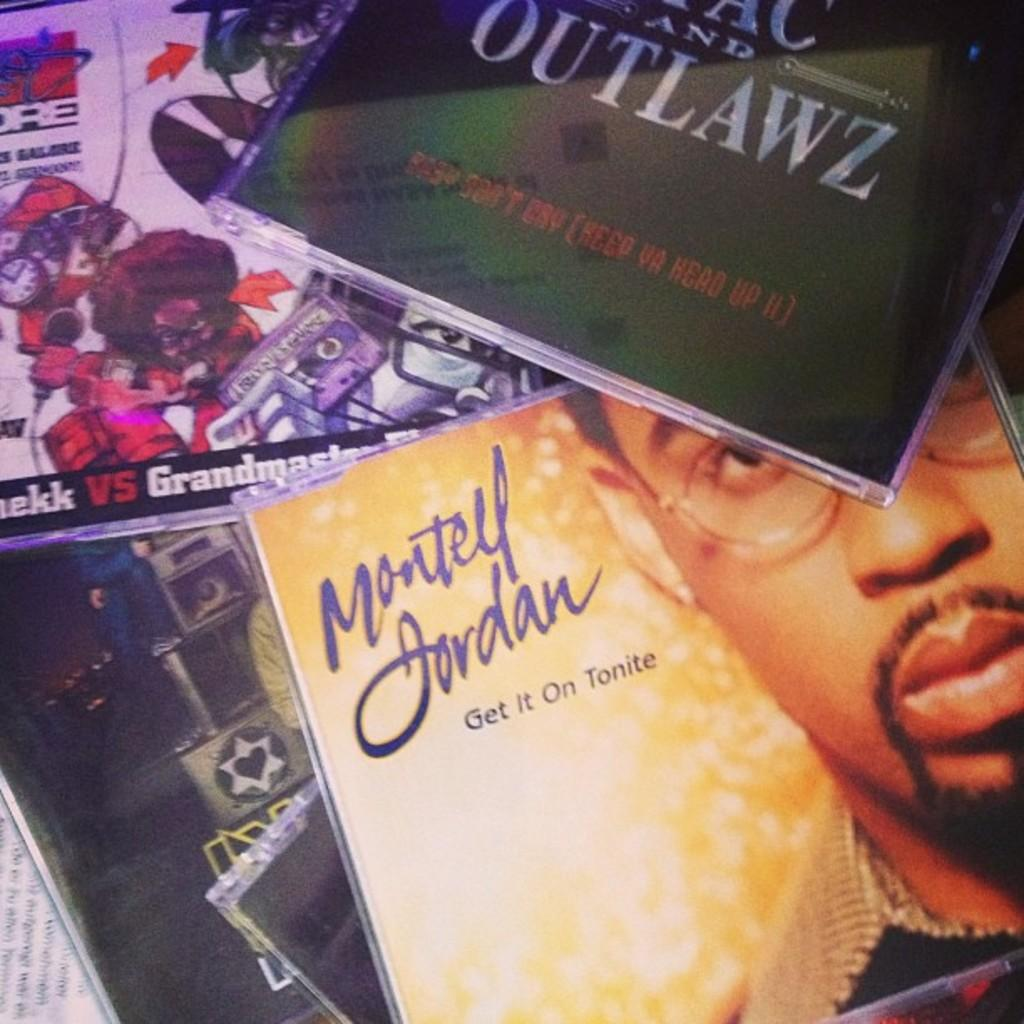<image>
Give a short and clear explanation of the subsequent image. A compact disc by the performer Montell Jordan is called Get It  On Tonite. 